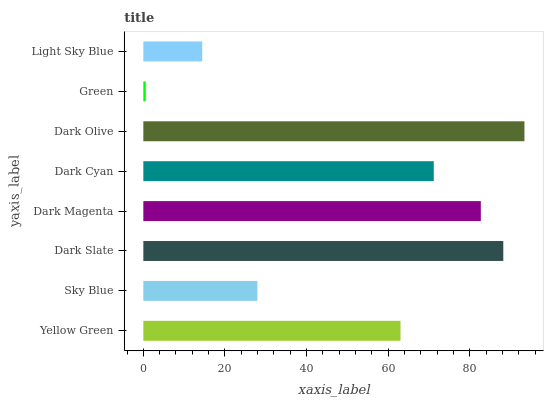Is Green the minimum?
Answer yes or no. Yes. Is Dark Olive the maximum?
Answer yes or no. Yes. Is Sky Blue the minimum?
Answer yes or no. No. Is Sky Blue the maximum?
Answer yes or no. No. Is Yellow Green greater than Sky Blue?
Answer yes or no. Yes. Is Sky Blue less than Yellow Green?
Answer yes or no. Yes. Is Sky Blue greater than Yellow Green?
Answer yes or no. No. Is Yellow Green less than Sky Blue?
Answer yes or no. No. Is Dark Cyan the high median?
Answer yes or no. Yes. Is Yellow Green the low median?
Answer yes or no. Yes. Is Yellow Green the high median?
Answer yes or no. No. Is Dark Cyan the low median?
Answer yes or no. No. 